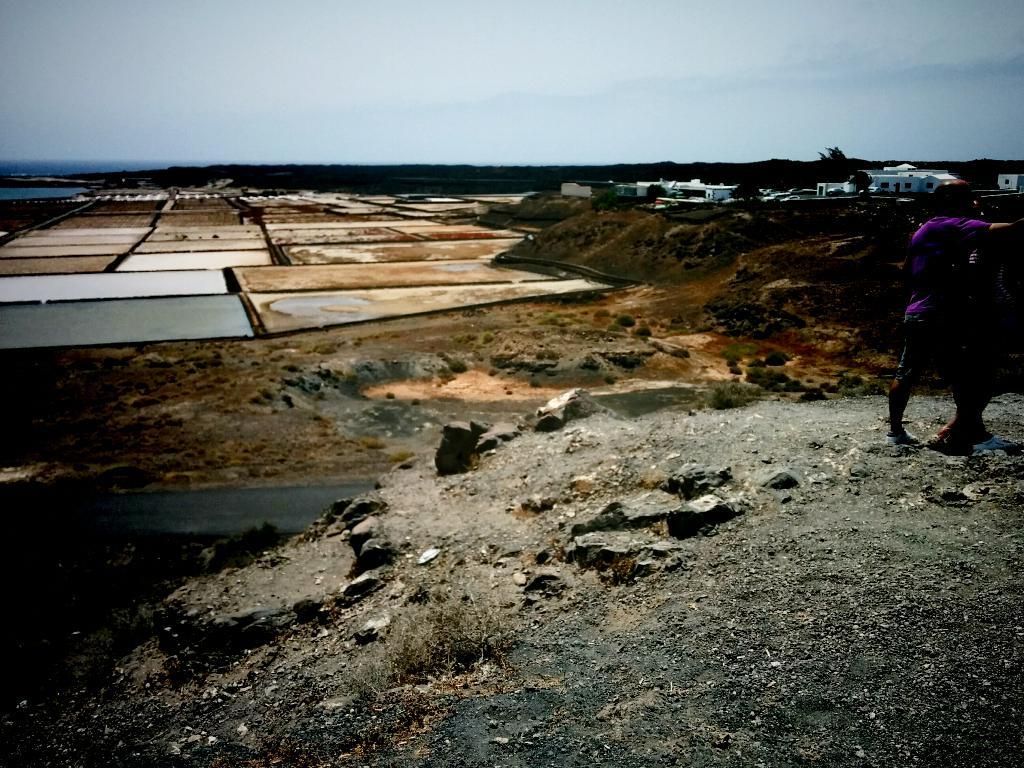How many persons are in the image? There are persons in the image, but the exact number is not specified. Where are the persons located in the image? The persons are on a hill in the image. What structures can be seen in the top right of the image? There are shelter houses in the top right of the image. What is visible at the top of the image? There is a sky at the top of the image. What type of carriage can be seen in the image? There is no carriage present in the image. How many clouds are visible in the sky in the image? The facts do not mention any clouds in the sky, so we cannot determine the number of clouds visible. 